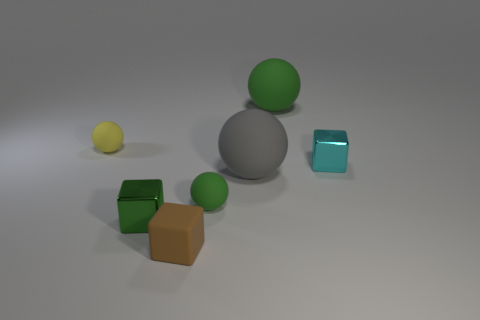Subtract all tiny green spheres. How many spheres are left? 3 Add 2 yellow things. How many objects exist? 9 Subtract all gray balls. How many balls are left? 3 Subtract all balls. How many objects are left? 3 Subtract 2 spheres. How many spheres are left? 2 Subtract all blue cylinders. How many green spheres are left? 2 Subtract all cyan balls. Subtract all gray cylinders. How many balls are left? 4 Subtract all metal cubes. Subtract all tiny green spheres. How many objects are left? 4 Add 6 small yellow objects. How many small yellow objects are left? 7 Add 4 big green rubber objects. How many big green rubber objects exist? 5 